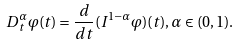<formula> <loc_0><loc_0><loc_500><loc_500>D ^ { \alpha } _ { t } \varphi ( t ) = \frac { d } { d t } ( I ^ { 1 - \alpha } \varphi ) ( t ) , \alpha \in ( 0 , 1 ) .</formula> 